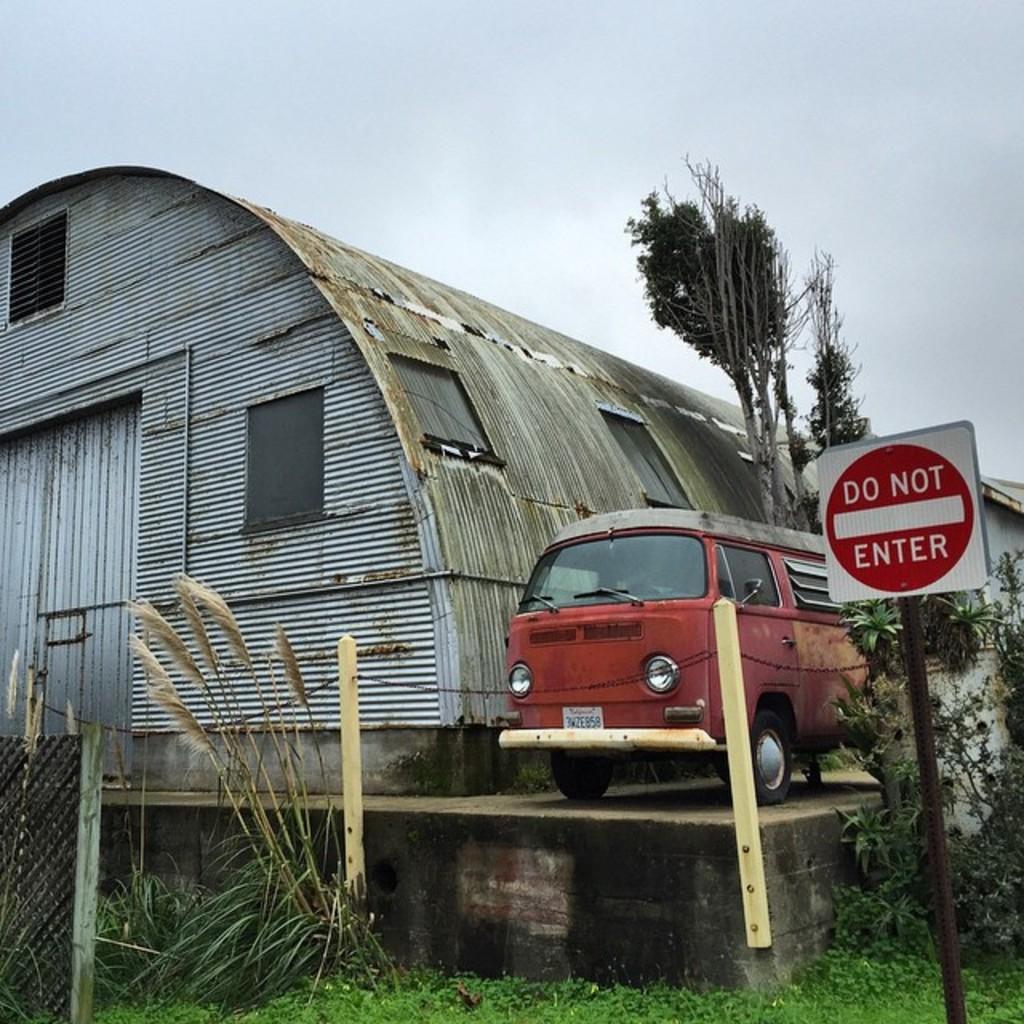Could you give a brief overview of what you see in this image? At the top there is a sky. Here we can see a shed. These are trees and a van in red color. Here we can see a sign board. This is a net and gross. 